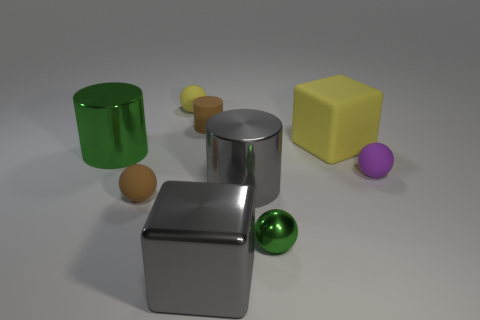There is a purple object that is the same shape as the tiny green metal object; what material is it?
Your response must be concise. Rubber. Are there any big green shiny cylinders on the right side of the gray thing that is in front of the small metallic sphere?
Give a very brief answer. No. Do the green object right of the gray metallic cube and the metal thing left of the tiny matte cylinder have the same size?
Make the answer very short. No. What number of tiny things are green blocks or shiny spheres?
Your answer should be very brief. 1. The big block in front of the cube on the right side of the small green thing is made of what material?
Provide a short and direct response. Metal. The small object that is the same color as the large matte object is what shape?
Your answer should be compact. Sphere. Is there a big gray block that has the same material as the purple thing?
Provide a short and direct response. No. Is the material of the tiny yellow object the same as the gray object on the right side of the large gray metal block?
Provide a short and direct response. No. There is a shiny sphere that is the same size as the purple rubber sphere; what is its color?
Offer a very short reply. Green. There is a gray shiny object behind the block that is on the left side of the large matte object; how big is it?
Give a very brief answer. Large. 